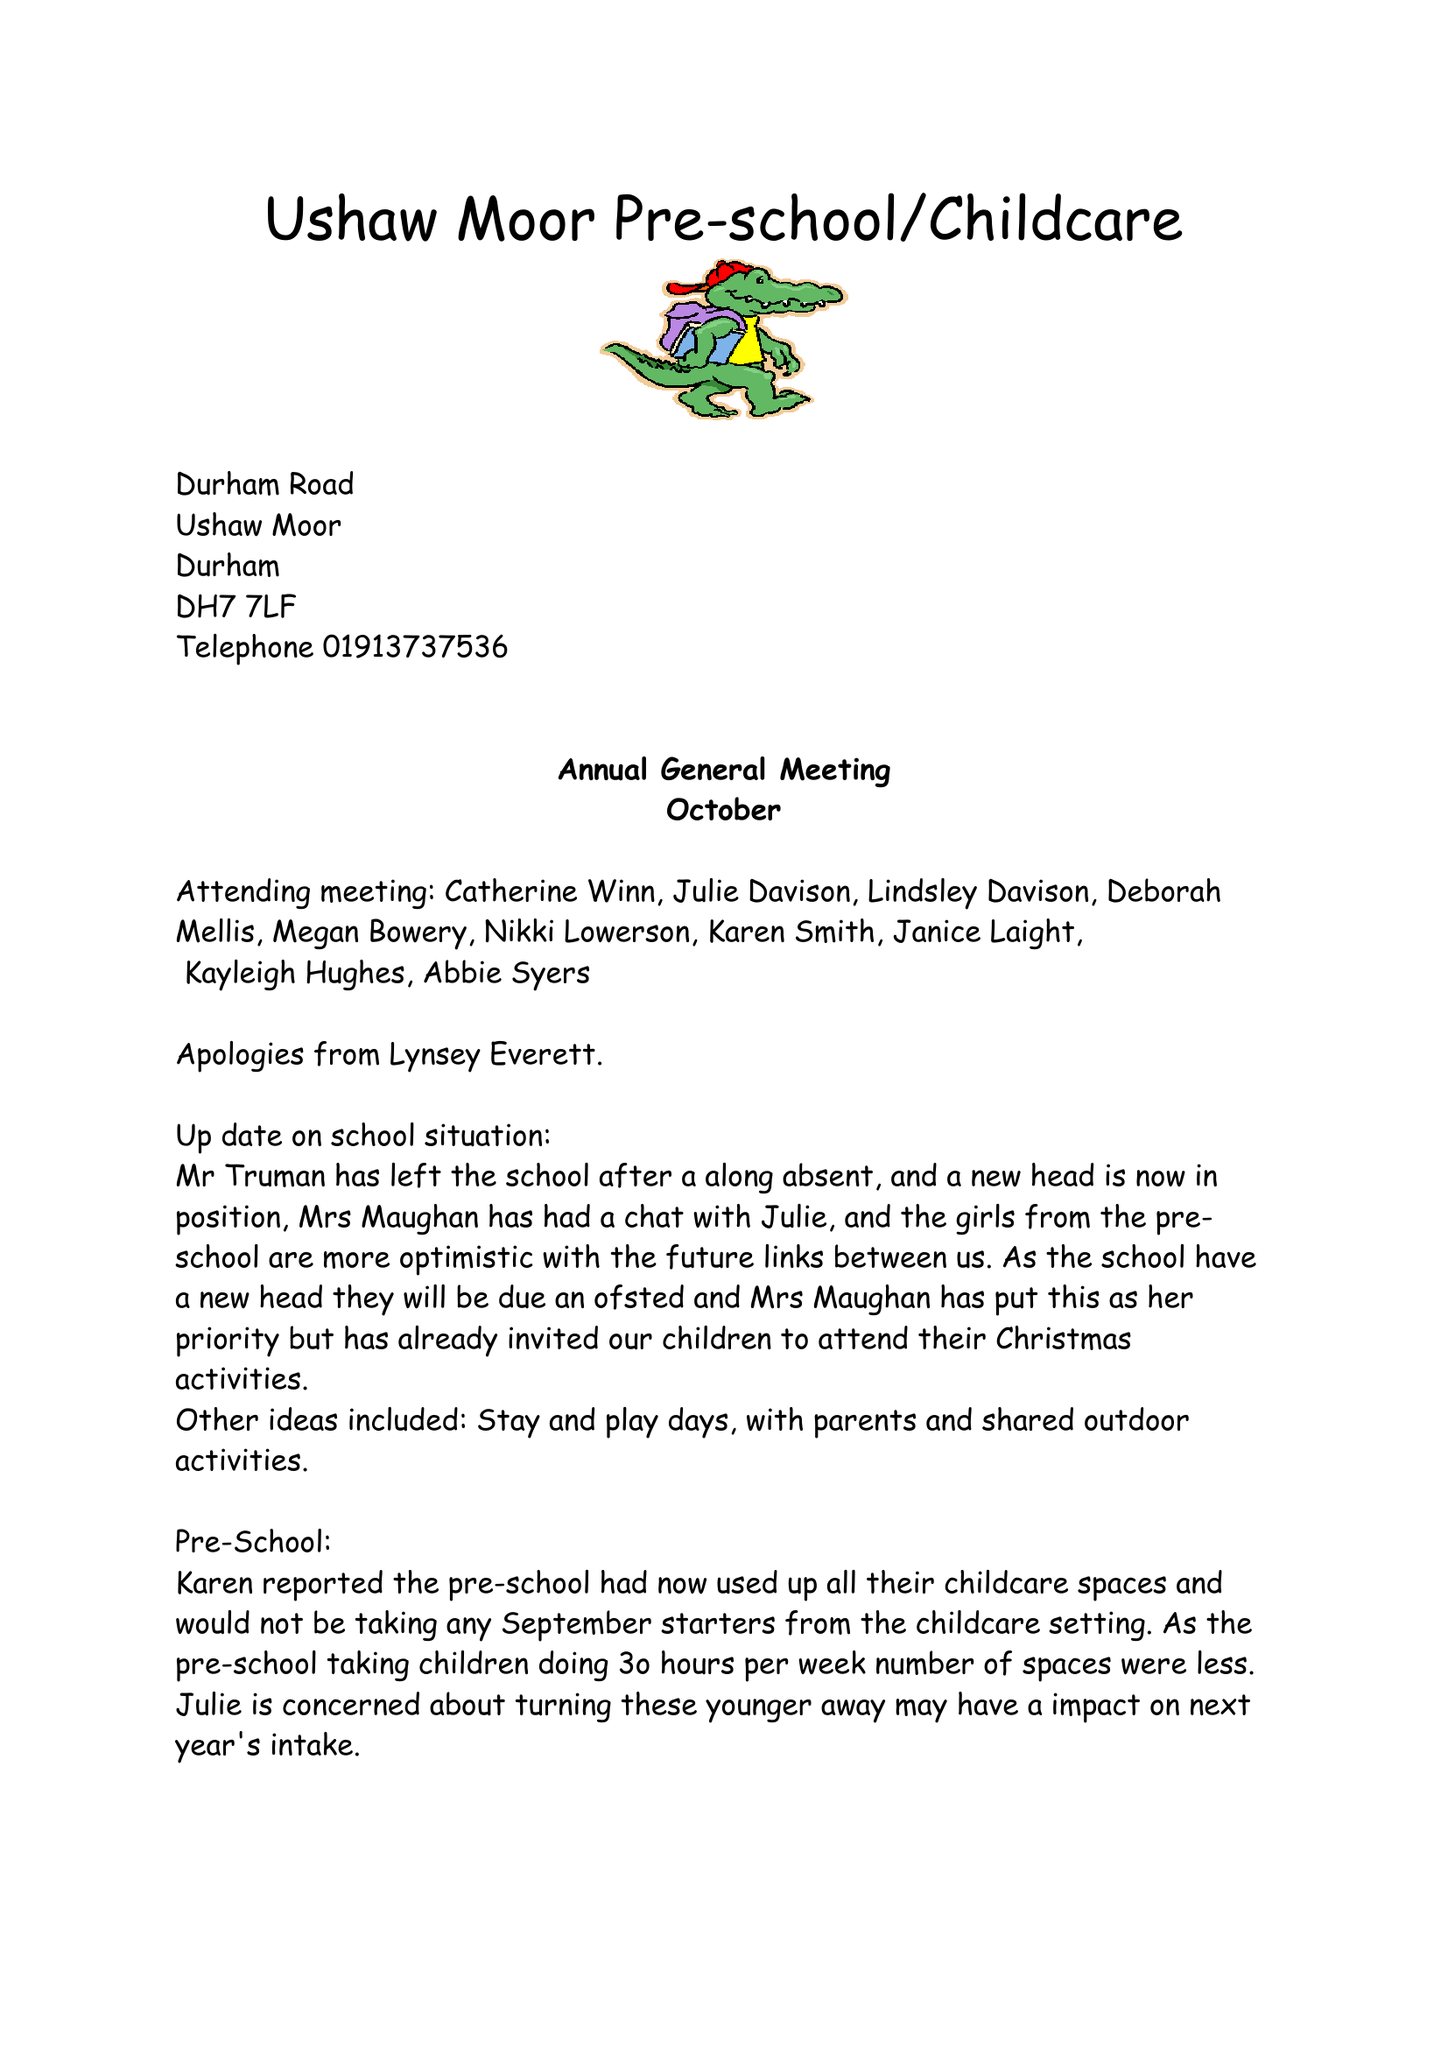What is the value for the charity_name?
Answer the question using a single word or phrase. Ushaw Moor Pre-School 